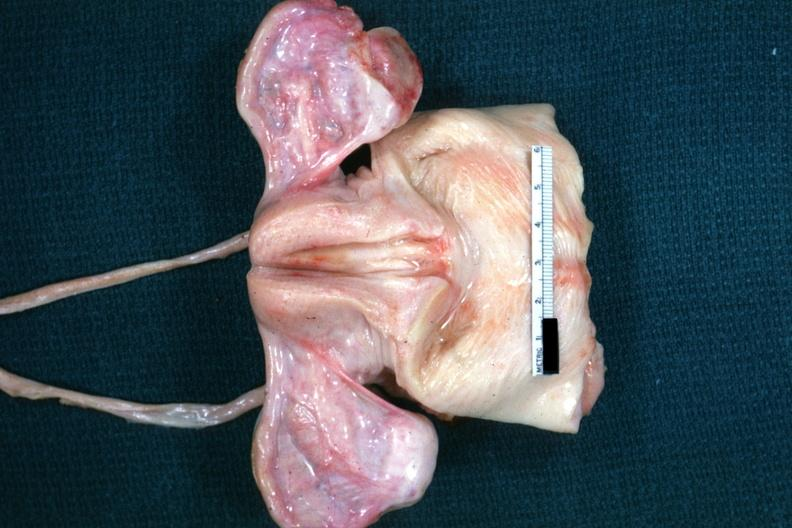how are truly normal ovaries non in this case of vacant sella but externally i can see nothing?
Answer the question using a single word or phrase. Functional 